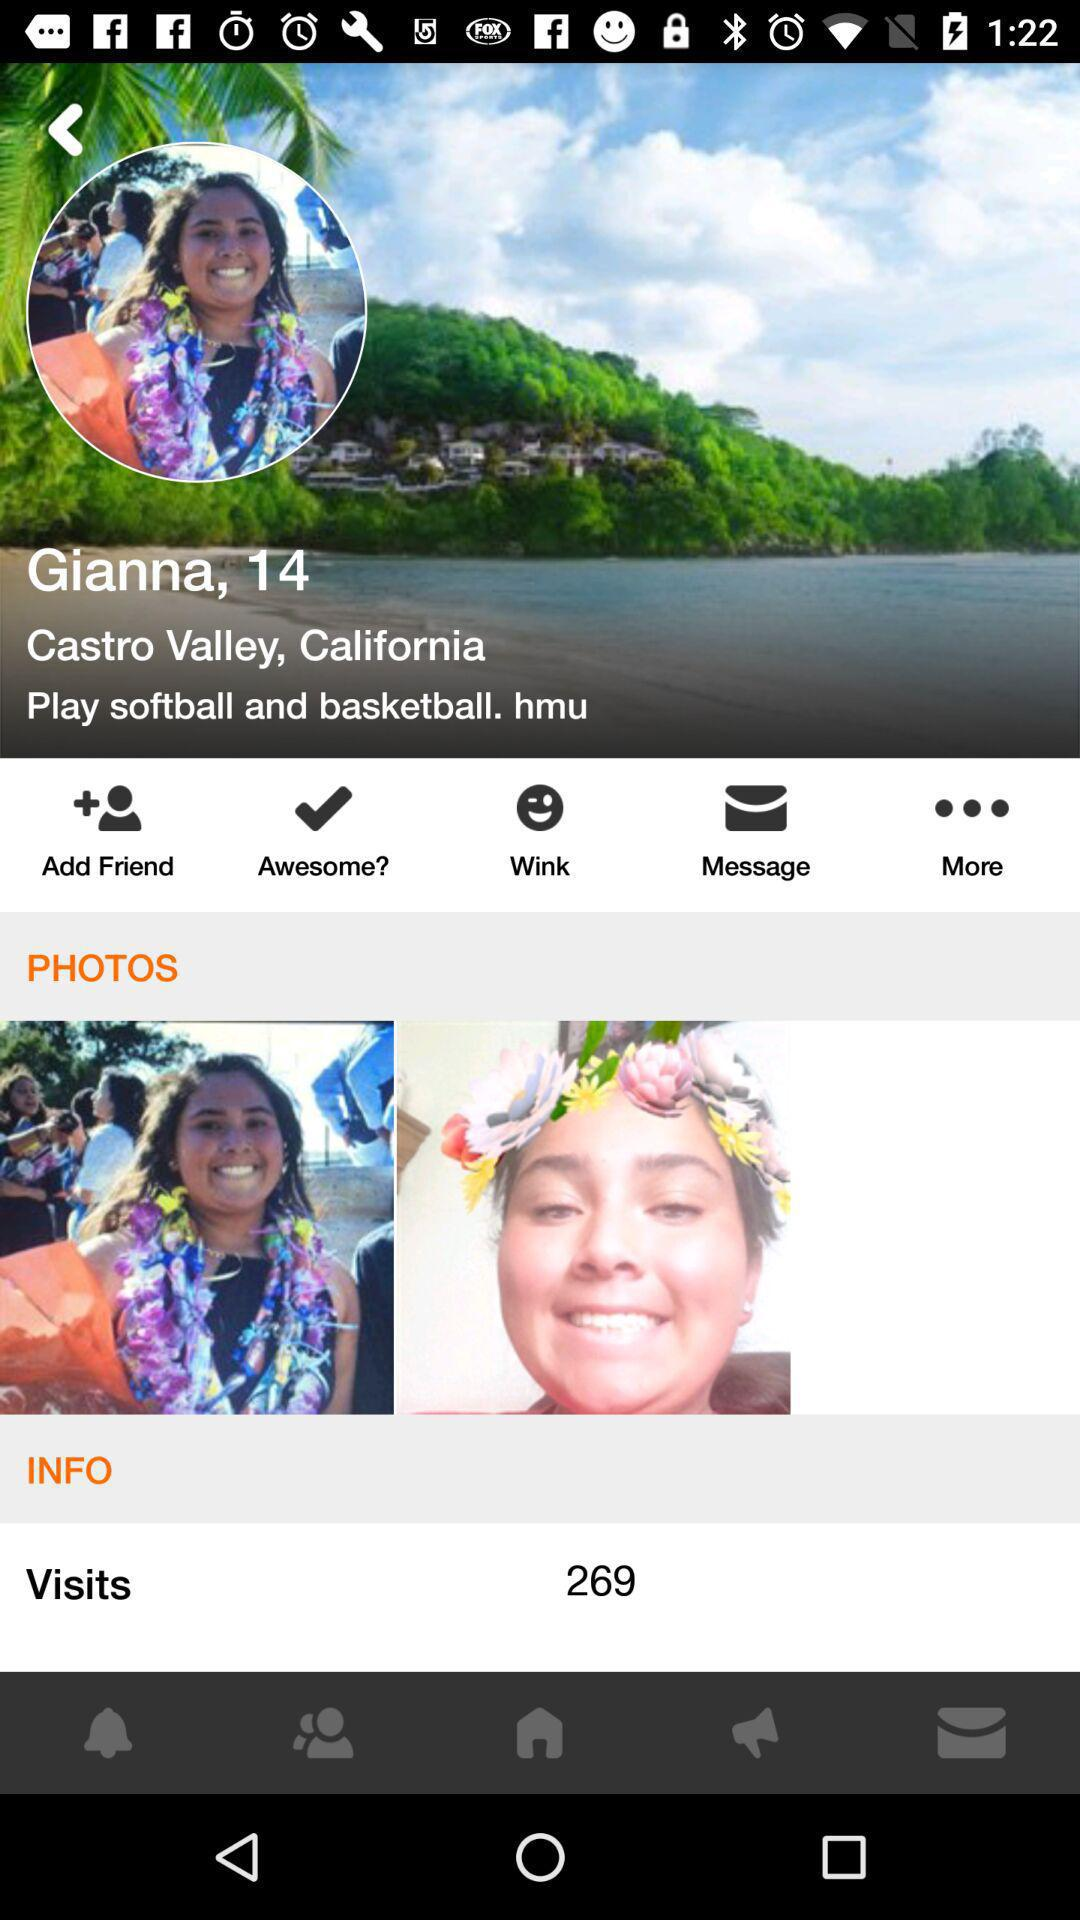How many visits in total are there on the profile? There are 269 visits on the profile. 